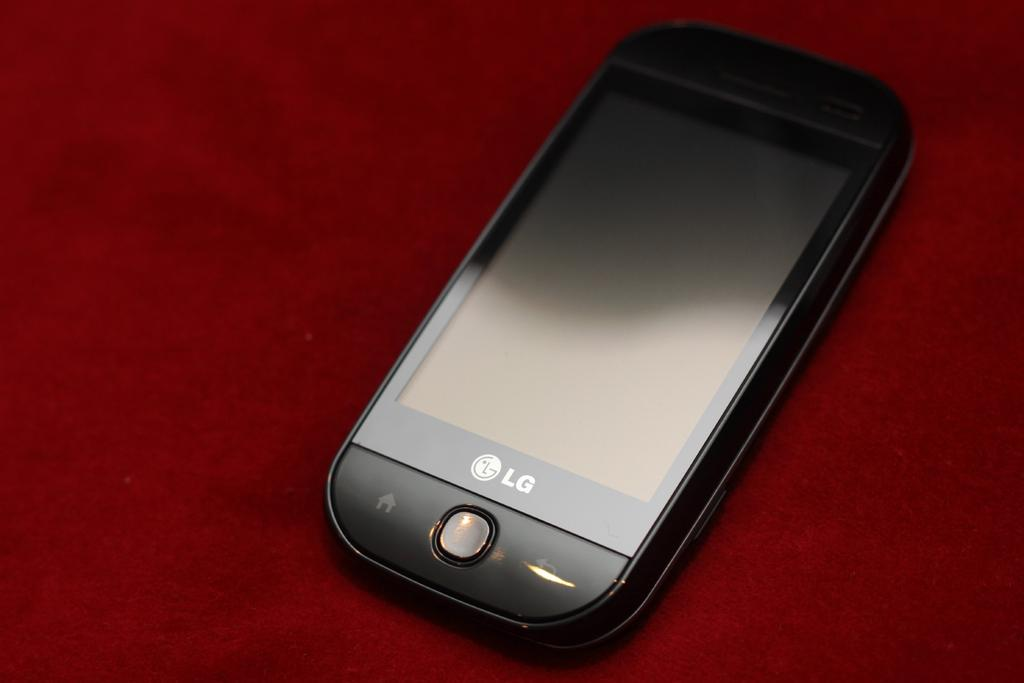What is the main subject of the image? The main subject of the image is a mobile. Can you describe the platform on which the mobile is placed? The mobile is on a red color platform. How many trees are visible in the image? There are no trees visible in the image, as the image only features a mobile on a red color platform. What type of leather material is used to make the mobile in the image? There is no leather material present in the image, as the mobile is not described as being made of any specific material. 